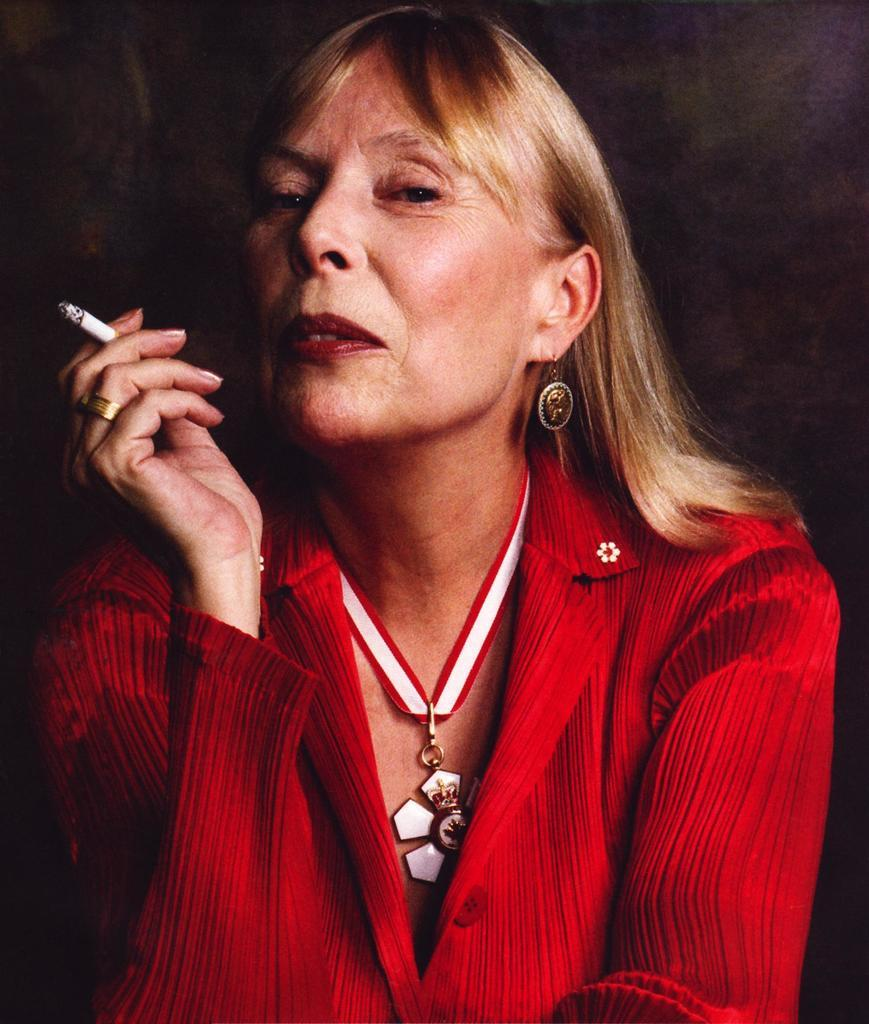Who is present in the image? There is a woman in the image. What is the woman holding in the image? The woman is holding a cigarette. Can you describe the background of the image? The background of the image is dark. What type of lumber can be seen in the image? There is no lumber present in the image; it features a woman holding a cigarette with a dark background. 